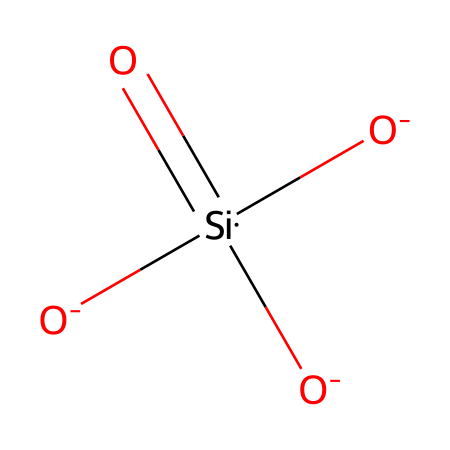What is the central atom in this chemical structure? The central atom can be identified in the SMILES representation. Here, [Si] indicates that silicon is the central atom connected to various functional groups and bonds.
Answer: silicon How many oxygen atoms are present? In the given SMILES, there are four [O] symbols indicating four oxygen atoms are present in the structure.
Answer: four What type of bonding is happening between silicon and oxygen? The silicon is double-bonded to one oxygen (indicated by the "=" in the SMILES) and single-bonded to three others (shown as [O-]), indicating a mixture of double and single bonds.
Answer: mixed bonding What is the charge on the oxygen atoms? Each of the oxygen atoms in the structure has a negative charge indicated by the [O-] notation, meaning they each carry a charge of -1.
Answer: negative How does this chemical contribute to the self-cleaning properties of coatings? The structural arrangement of nanoscale silica particles enhances photocatalytic activity, which degrades organic pollutants on surfaces when exposed to light, contributing to self-cleaning.
Answer: photocatalytic activity What is the significance of using nanoscale silica in coatings? Nanoscale silica provides a large surface area, enhancing adhesion and durability of coatings while improving the hydrophilic or hydrophobic properties of surfaces, which is essential for self-cleaning.
Answer: large surface area 